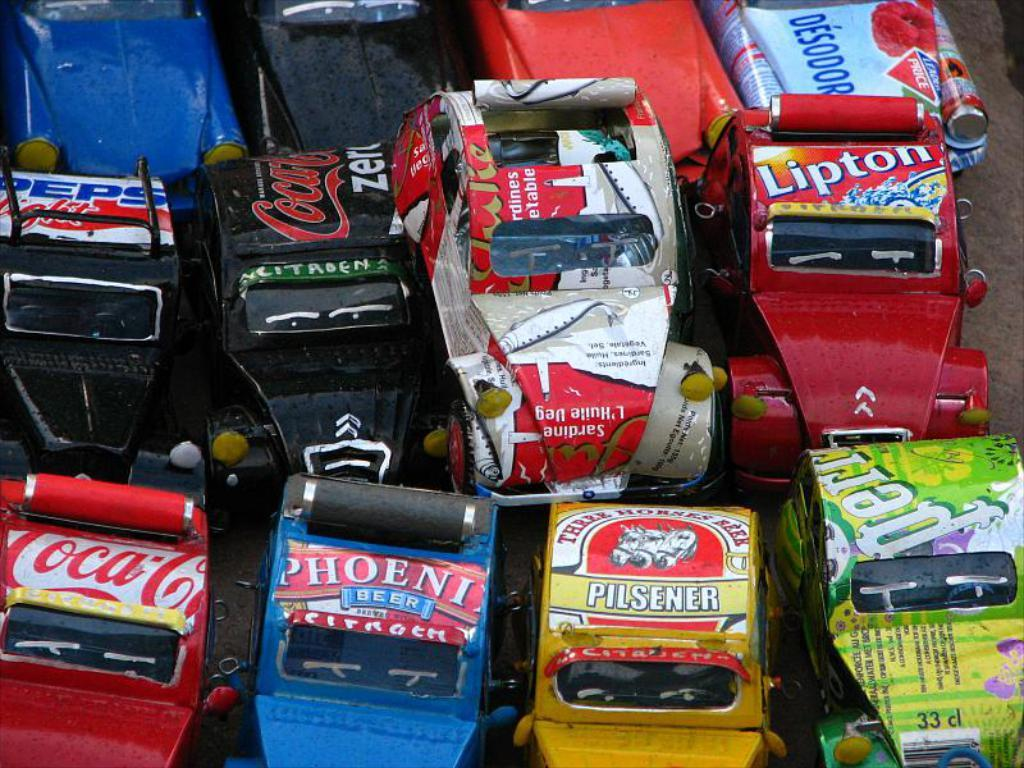What type of objects are present in the image? There are toy vehicles in the image. Where are the toy vehicles located? The toy vehicles are on an object. How many frogs can be seen swimming in the vessel in the image? There are no frogs or vessels present in the image; it features toy vehicles on an object. 